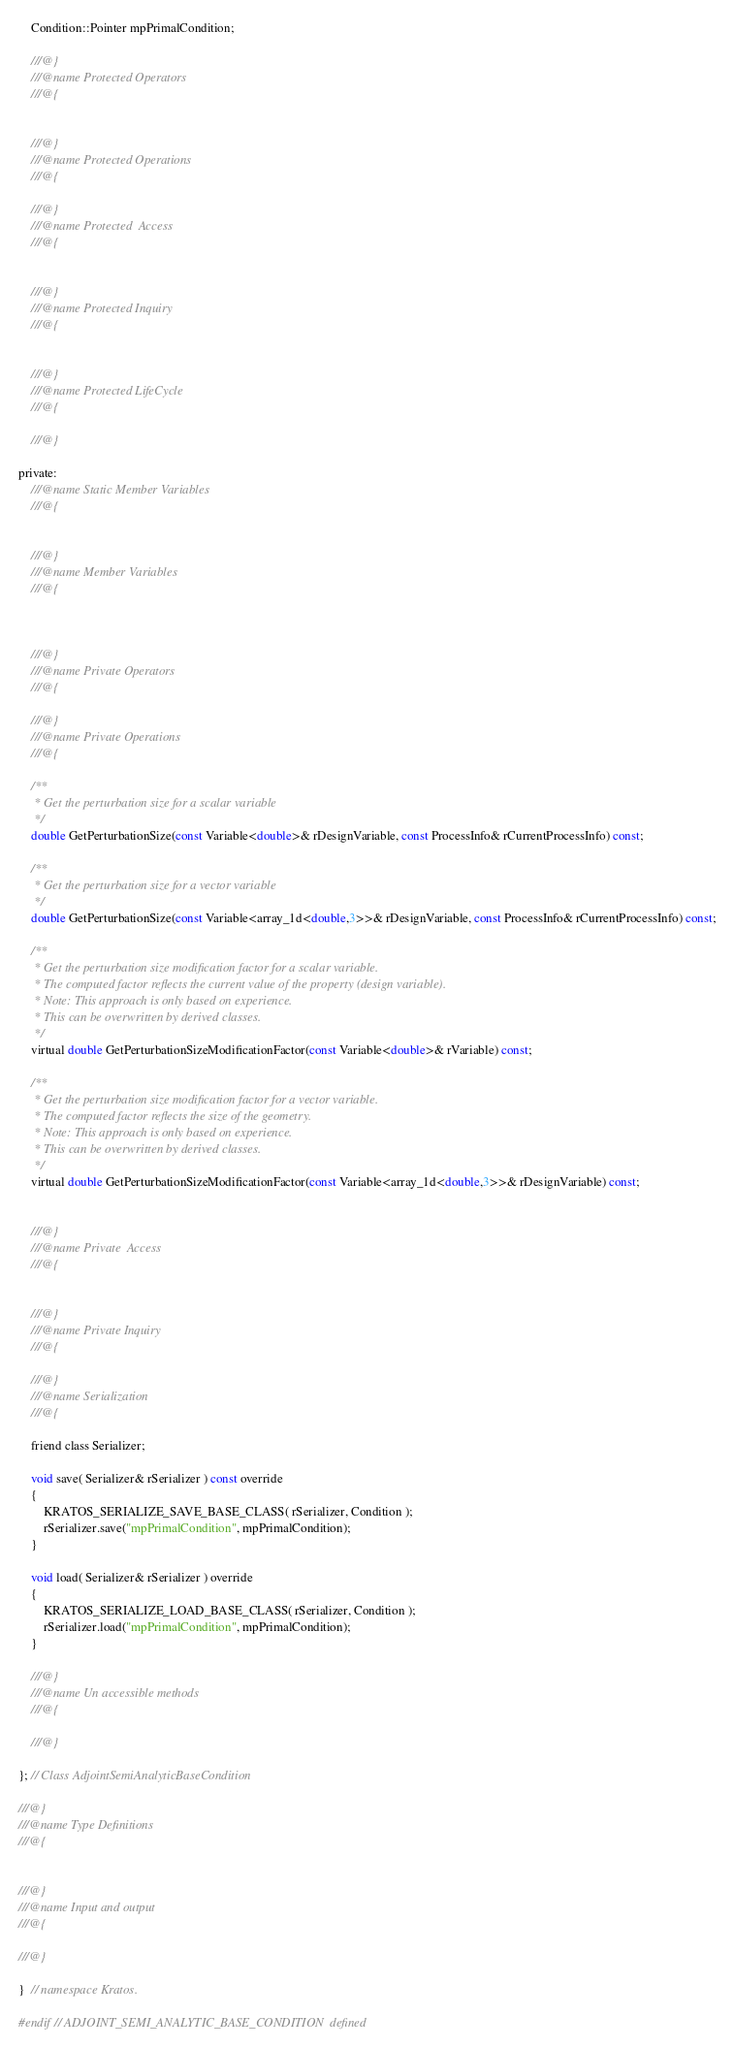Convert code to text. <code><loc_0><loc_0><loc_500><loc_500><_C_>    Condition::Pointer mpPrimalCondition;

    ///@}
    ///@name Protected Operators
    ///@{


    ///@}
    ///@name Protected Operations
    ///@{

    ///@}
    ///@name Protected  Access
    ///@{


    ///@}
    ///@name Protected Inquiry
    ///@{


    ///@}
    ///@name Protected LifeCycle
    ///@{

    ///@}

private:
    ///@name Static Member Variables
    ///@{


    ///@}
    ///@name Member Variables
    ///@{



    ///@}
    ///@name Private Operators
    ///@{

    ///@}
    ///@name Private Operations
    ///@{

    /**
     * Get the perturbation size for a scalar variable
     */
    double GetPerturbationSize(const Variable<double>& rDesignVariable, const ProcessInfo& rCurrentProcessInfo) const;

    /**
     * Get the perturbation size for a vector variable
     */
    double GetPerturbationSize(const Variable<array_1d<double,3>>& rDesignVariable, const ProcessInfo& rCurrentProcessInfo) const;

    /**
     * Get the perturbation size modification factor for a scalar variable.
     * The computed factor reflects the current value of the property (design variable).
     * Note: This approach is only based on experience.
     * This can be overwritten by derived classes.
     */
    virtual double GetPerturbationSizeModificationFactor(const Variable<double>& rVariable) const;

    /**
     * Get the perturbation size modification factor for a vector variable.
     * The computed factor reflects the size of the geometry.
     * Note: This approach is only based on experience.
     * This can be overwritten by derived classes.
     */
    virtual double GetPerturbationSizeModificationFactor(const Variable<array_1d<double,3>>& rDesignVariable) const;


    ///@}
    ///@name Private  Access
    ///@{


    ///@}
    ///@name Private Inquiry
    ///@{

    ///@}
    ///@name Serialization
    ///@{

    friend class Serializer;

    void save( Serializer& rSerializer ) const override
    {
        KRATOS_SERIALIZE_SAVE_BASE_CLASS( rSerializer, Condition );
        rSerializer.save("mpPrimalCondition", mpPrimalCondition);
    }

    void load( Serializer& rSerializer ) override
    {
        KRATOS_SERIALIZE_LOAD_BASE_CLASS( rSerializer, Condition );
        rSerializer.load("mpPrimalCondition", mpPrimalCondition);
    }

    ///@}
    ///@name Un accessible methods
    ///@{

    ///@}

}; // Class AdjointSemiAnalyticBaseCondition

///@}
///@name Type Definitions
///@{


///@}
///@name Input and output
///@{

///@}

}  // namespace Kratos.

#endif // ADJOINT_SEMI_ANALYTIC_BASE_CONDITION  defined


</code> 